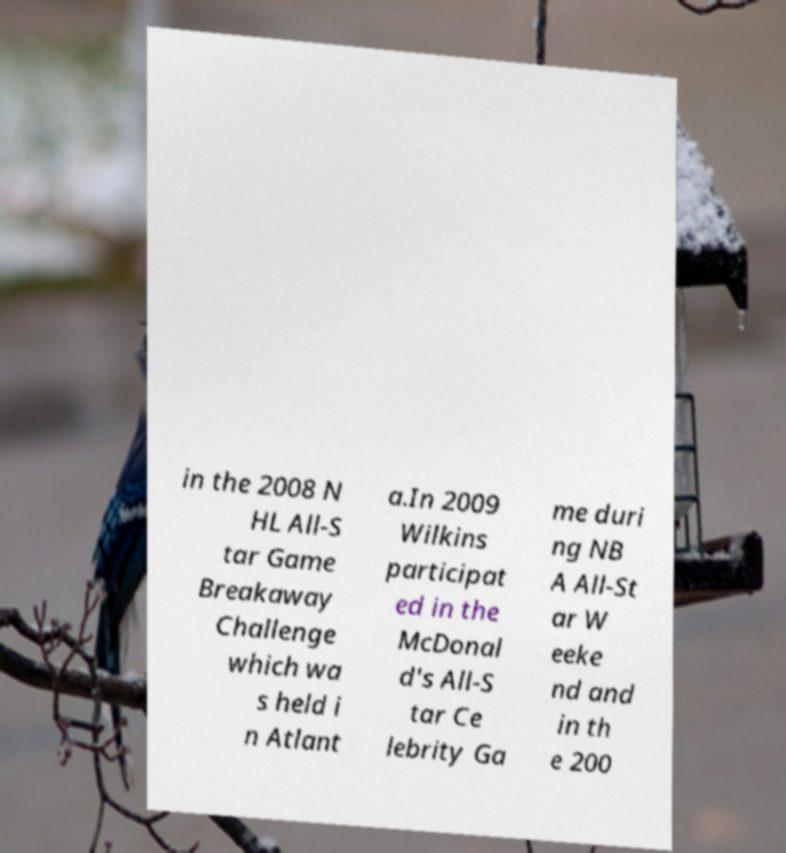Could you extract and type out the text from this image? in the 2008 N HL All-S tar Game Breakaway Challenge which wa s held i n Atlant a.In 2009 Wilkins participat ed in the McDonal d's All-S tar Ce lebrity Ga me duri ng NB A All-St ar W eeke nd and in th e 200 